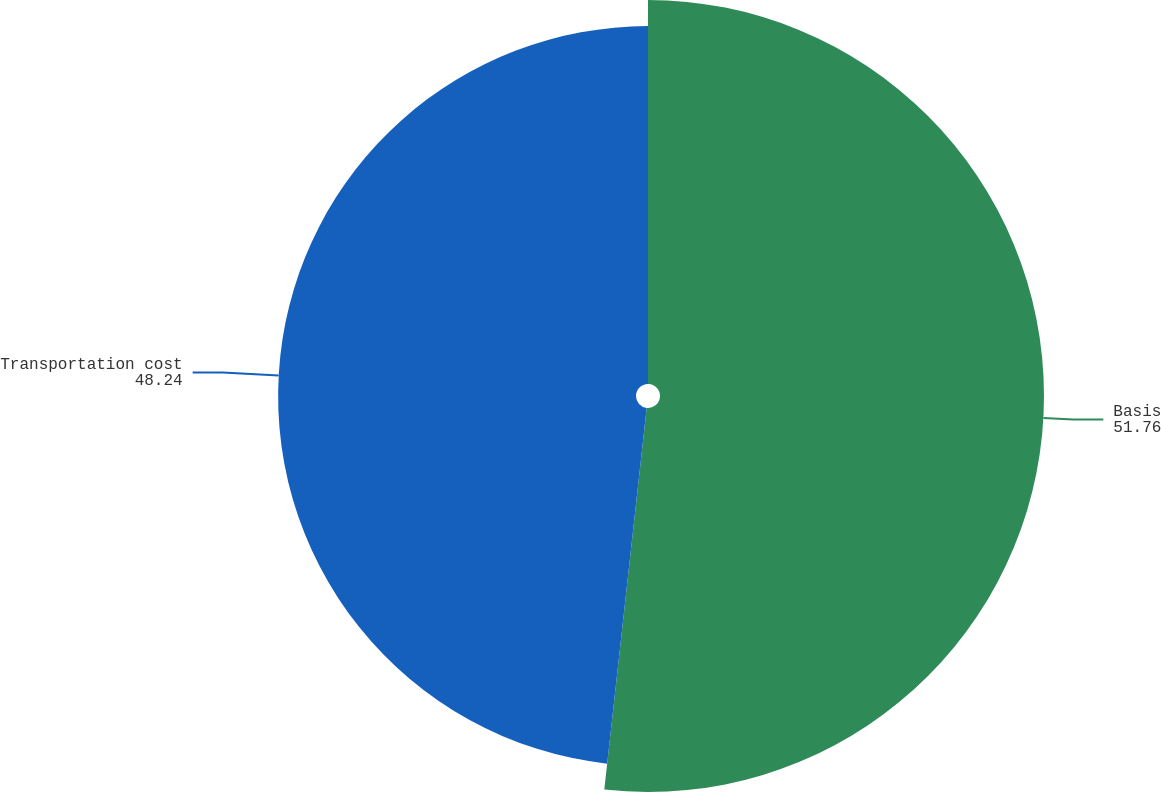Convert chart. <chart><loc_0><loc_0><loc_500><loc_500><pie_chart><fcel>Basis<fcel>Transportation cost<nl><fcel>51.76%<fcel>48.24%<nl></chart> 